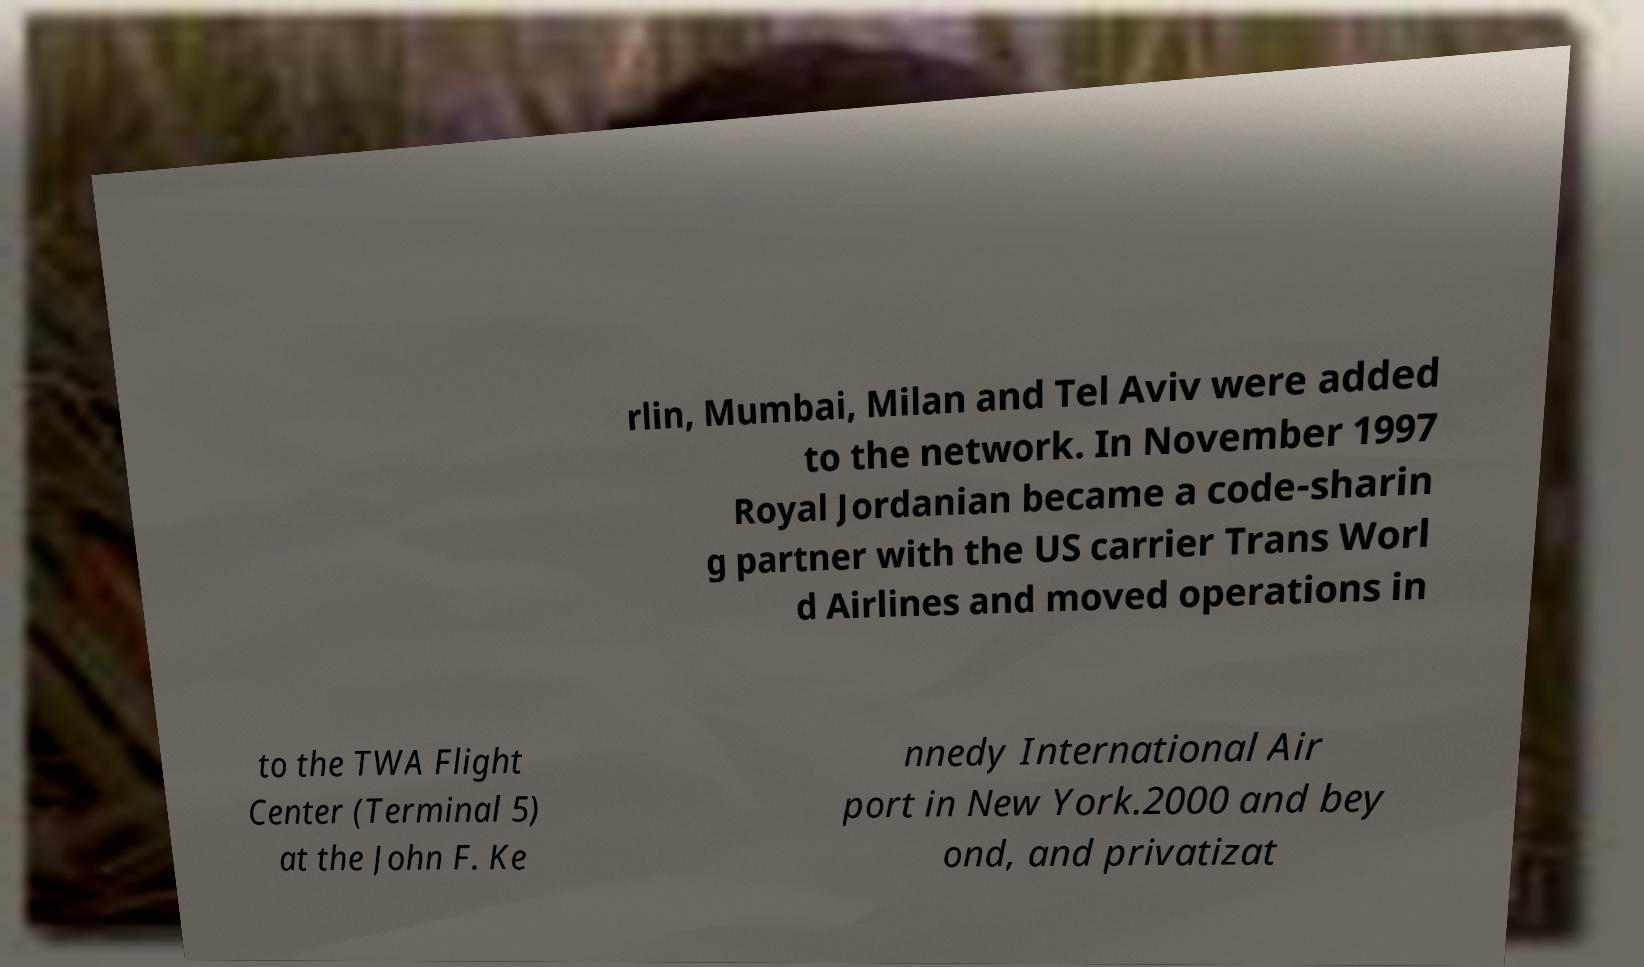Could you assist in decoding the text presented in this image and type it out clearly? rlin, Mumbai, Milan and Tel Aviv were added to the network. In November 1997 Royal Jordanian became a code-sharin g partner with the US carrier Trans Worl d Airlines and moved operations in to the TWA Flight Center (Terminal 5) at the John F. Ke nnedy International Air port in New York.2000 and bey ond, and privatizat 